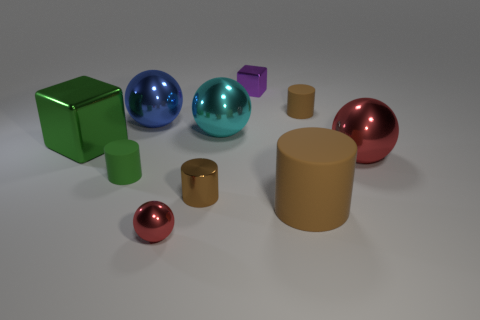Do the blue ball and the cyan shiny thing have the same size?
Your answer should be very brief. Yes. What number of things are either brown matte cylinders on the right side of the large green thing or small cyan matte cylinders?
Your answer should be compact. 2. Is the purple object the same shape as the big green metal object?
Give a very brief answer. Yes. What number of other things are the same size as the green rubber thing?
Provide a short and direct response. 4. The tiny ball has what color?
Keep it short and to the point. Red. What number of tiny things are either blue matte blocks or green matte objects?
Offer a very short reply. 1. Is the size of the cylinder that is to the right of the big rubber cylinder the same as the metal cube right of the tiny metallic sphere?
Offer a terse response. Yes. What is the size of the cyan object that is the same shape as the blue metallic object?
Offer a terse response. Large. Are there more big blue balls on the left side of the green cube than matte things behind the big cyan metal thing?
Keep it short and to the point. No. What is the material of the object that is behind the green matte cylinder and on the left side of the large blue sphere?
Keep it short and to the point. Metal. 